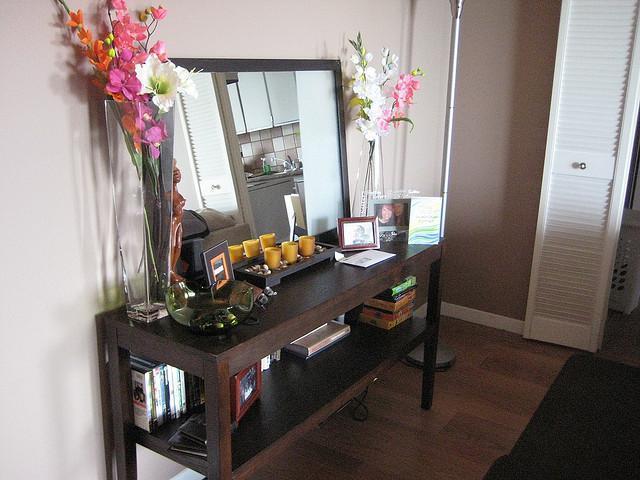What is behind the small table with the flowers?
Choose the correct response and explain in the format: 'Answer: answer
Rationale: rationale.'
Options: Baby, glasses, mirror, cat. Answer: mirror.
Rationale: The mirror is behind. 